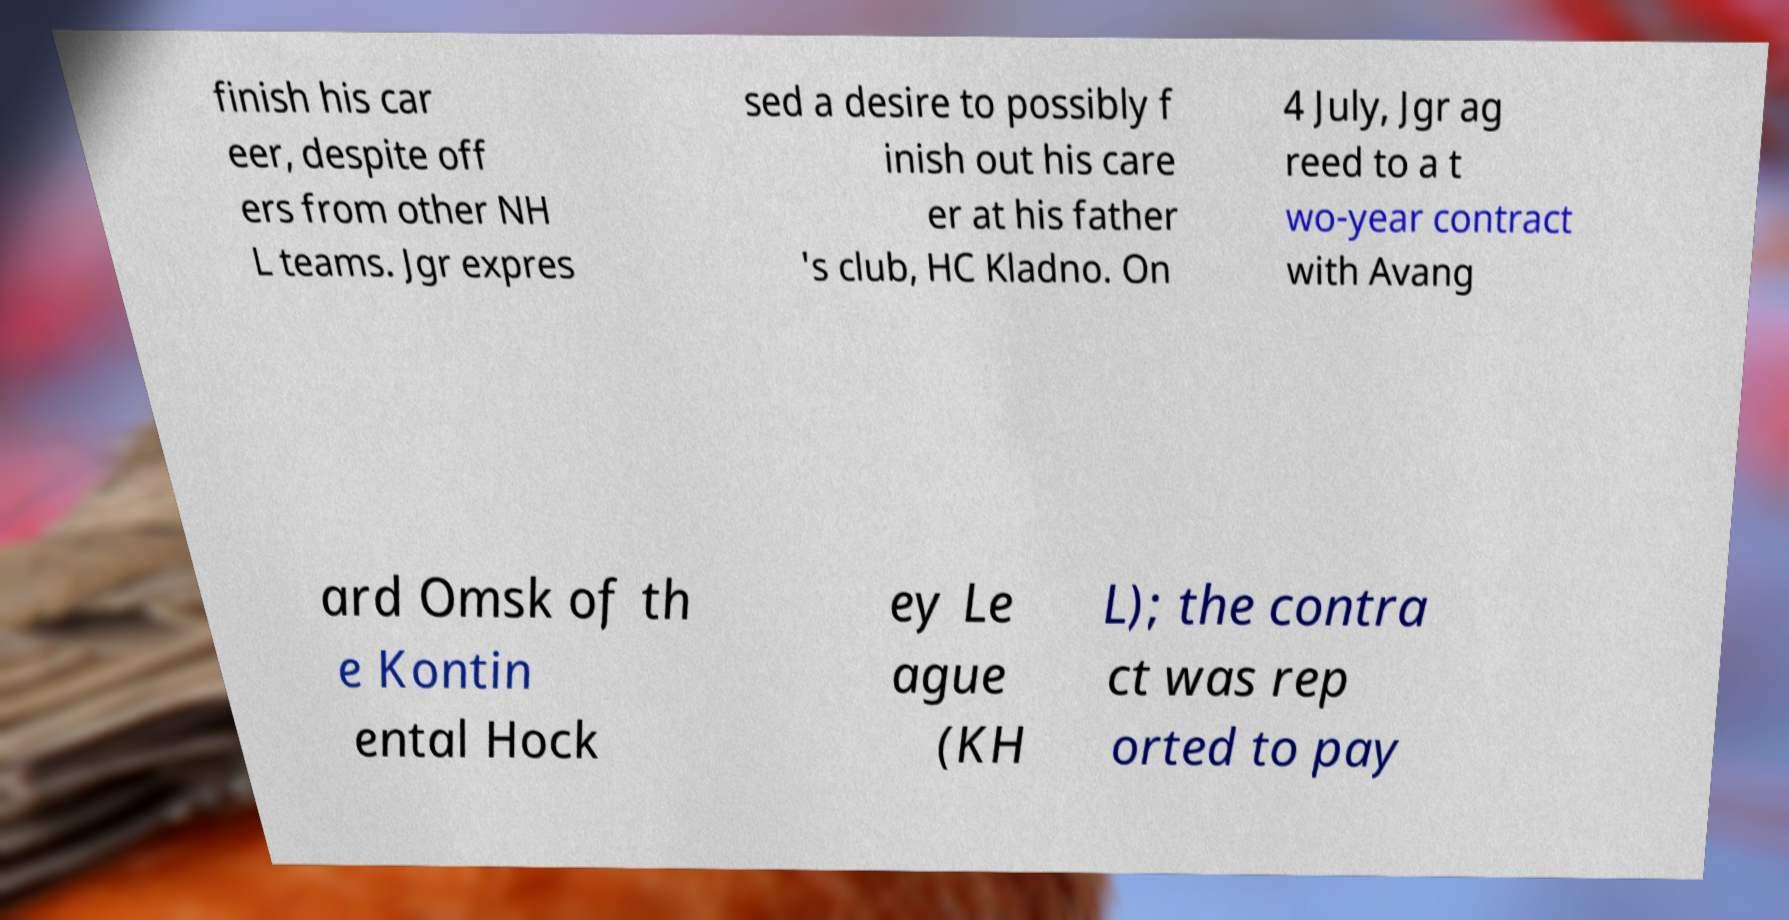Can you accurately transcribe the text from the provided image for me? finish his car eer, despite off ers from other NH L teams. Jgr expres sed a desire to possibly f inish out his care er at his father 's club, HC Kladno. On 4 July, Jgr ag reed to a t wo-year contract with Avang ard Omsk of th e Kontin ental Hock ey Le ague (KH L); the contra ct was rep orted to pay 